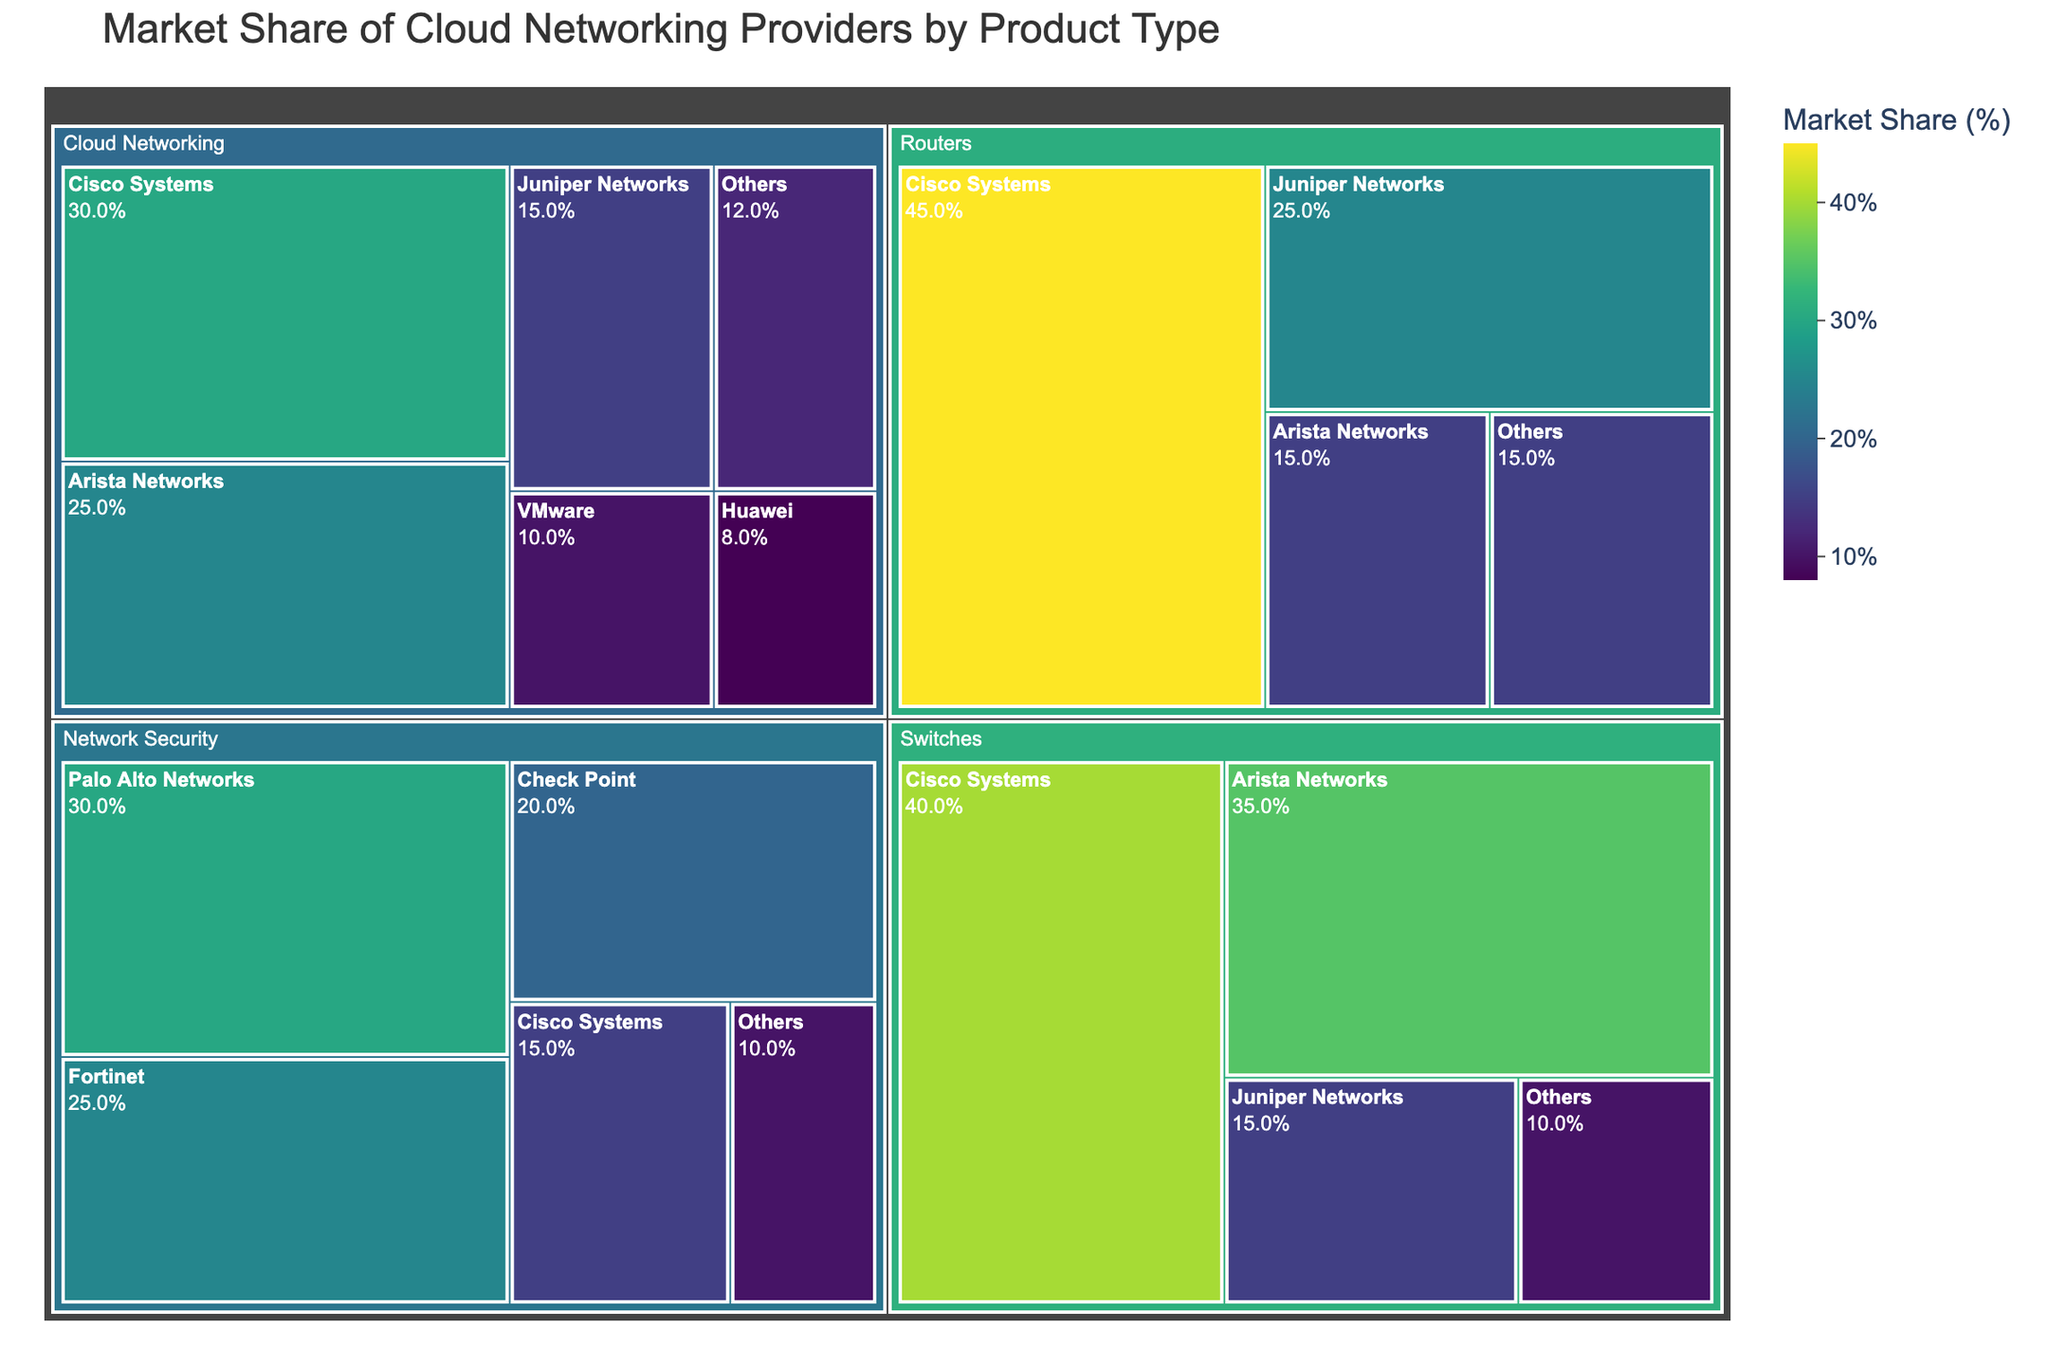What is the market share of Arista Networks in the Cloud Networking category? Look at the Cloud Networking category section of the treemap and identify the market share for Arista Networks.
Answer: 25% Which provider has the largest market share in the Switches category? Locate the Switches category and compare the market shares of all providers. Identify the provider with the highest percentage.
Answer: Cisco Systems What is the combined market share of Arista Networks and Cisco Systems across all categories? Sum the market shares of Arista Networks and Cisco Systems from each fragmented category (Cloud Networking, Switches, Routers, Network Security). Add the percentages together: Arista Networks (25+35+15) + Cisco Systems (30+40+45+15).
Answer: 205% In the Cloud Networking category, who has a higher market share: VMware or Huawei? Compare the market shares of VMware and Huawei within the Cloud Networking section of the treemap.
Answer: VMware How much larger is the market share of Cisco Systems than Arista Networks in the Routers category? Subtract the market share of Arista Networks from Cisco Systems within the Routers category. Cisco Systems has 45%, and Arista Networks has 15%. So, 45% - 15%.
Answer: 30% Which provider appears across the most categories? Identify the providers in all the categories and count their occurrences. The provider listed in the greatest number of categories is the answer.
Answer: Cisco Systems What's the total market share of "Others" across all categories? Sum the market share percentages for "Others" in each category: Cloud Networking, Switches, Routers, and Network Security. So, we have (12+10+15+10).
Answer: 47% What is the dominant color associated with the highest market share values? Look at the color gradient associated with the highest market share values in the treemap (highest percentages). The color scale is "Viridis," so find the dominant color for values around 45%.
Answer: Dark green Which category has the smallest total market share for Arista Networks? Compare the market shares of Arista Networks across all categories (Cloud Networking, Switches, Routers). Identify the lowest percentage value.
Answer: Routers Which provider has the second largest market share in the Network Security category? In the Network Security category, compare all the market shares and identify the second largest.
Answer: Fortinet 